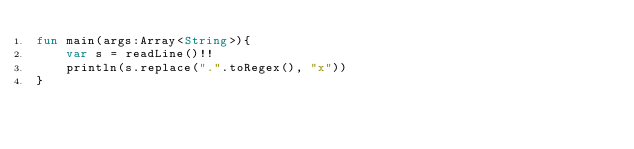<code> <loc_0><loc_0><loc_500><loc_500><_Kotlin_>fun main(args:Array<String>){
    var s = readLine()!!
    println(s.replace(".".toRegex(), "x"))
}</code> 